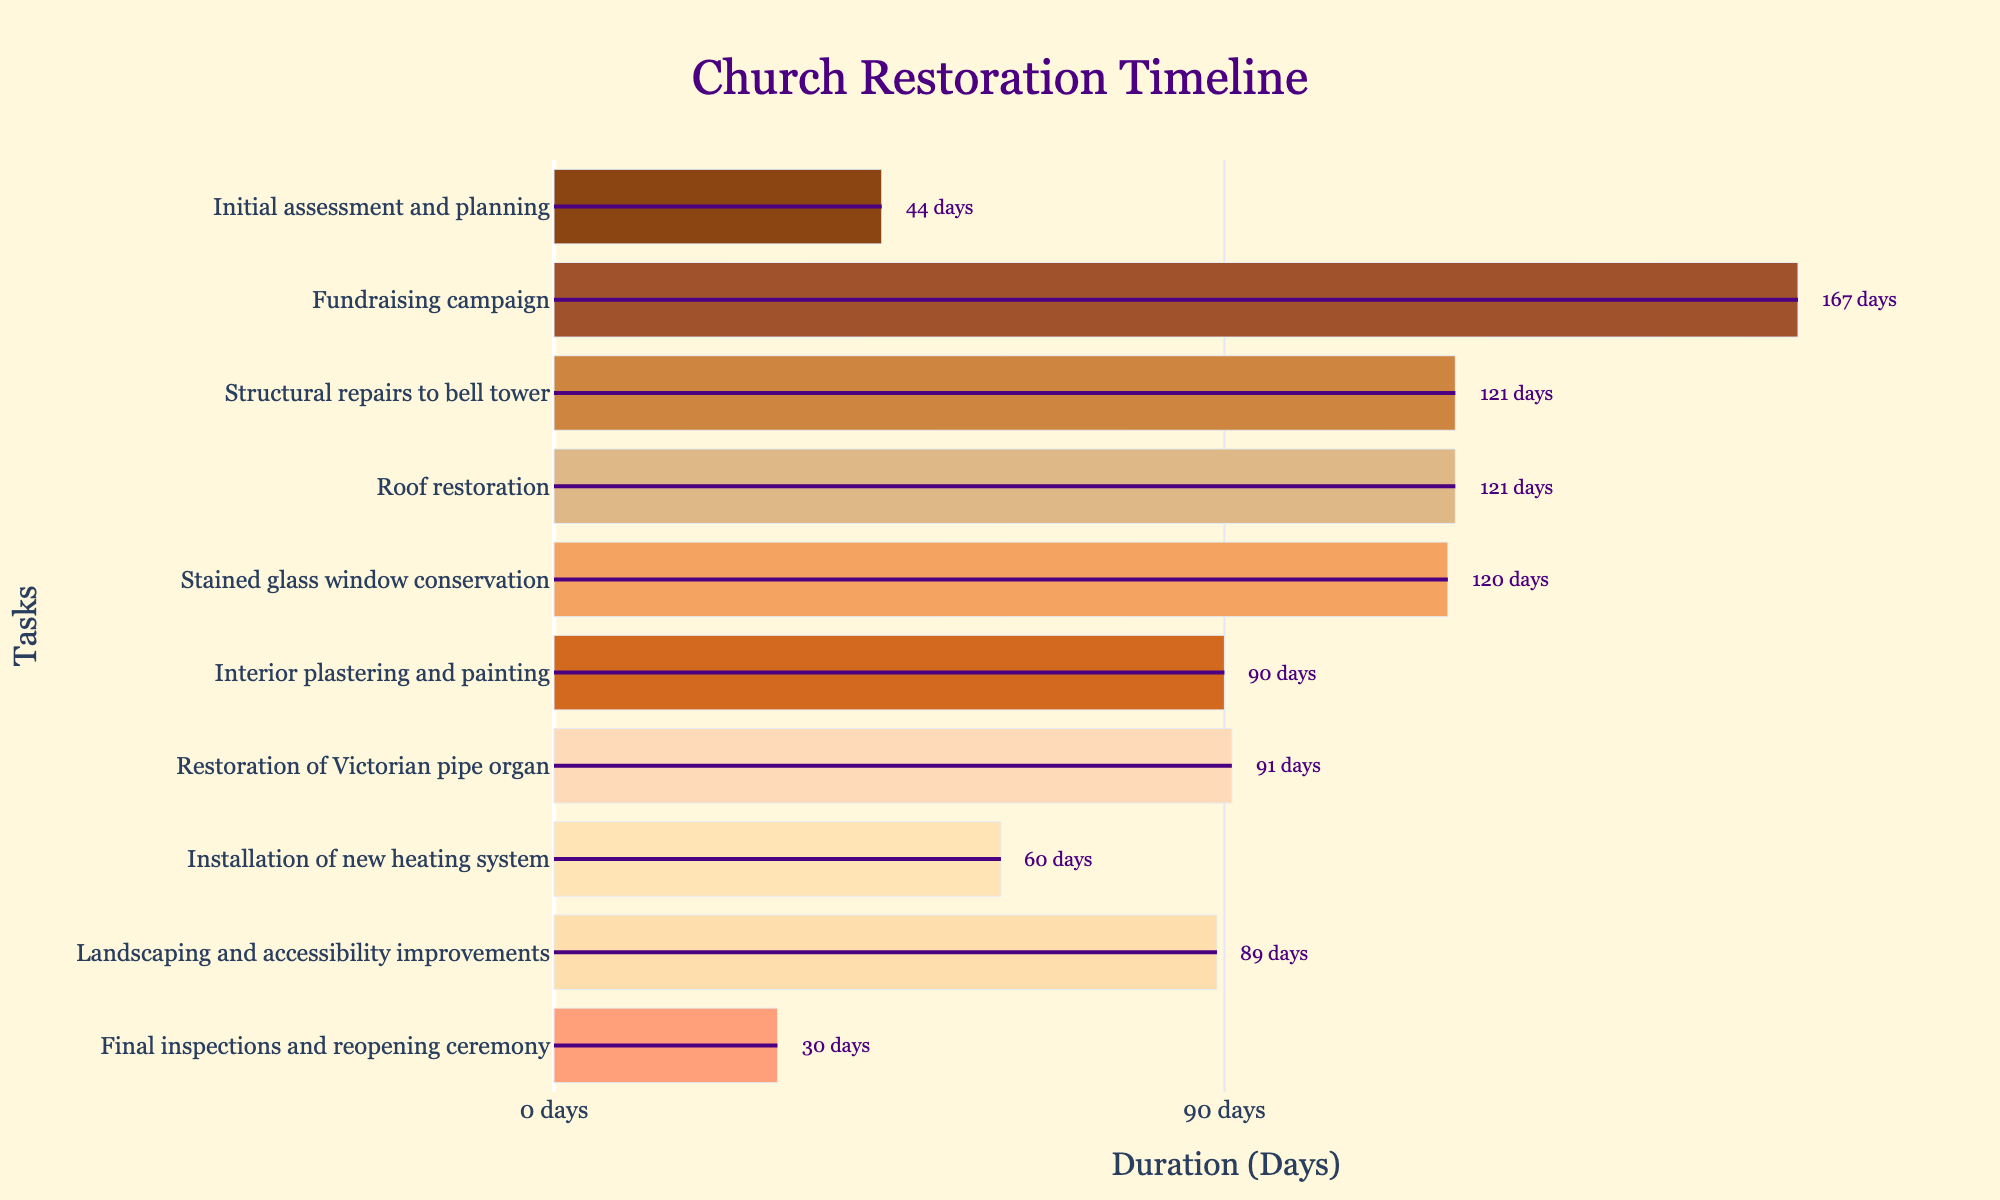what is the title of the chart? The title of the chart is given at the top center of the figure. It reads "Church Restoration Timeline".
Answer: Church Restoration Timeline What is the duration of the "Roof restoration" task? The "Roof restoration" task starts on August 1, 2024, and ends on November 30, 2024. The difference between these dates is 122 days.
Answer: 122 days Which task has the shortest duration? Looking at the chart, the task with the shortest bar length (duration) is the "Final inspections and reopening ceremony," lasting 31 days.
Answer: Final inspections and reopening ceremony How much longer does the "Fundraising campaign" run compared to the "Initial assessment and planning"? The "Fundraising campaign" lasts from October 16, 2023, to March 31, 2024, which is 167 days. The "Initial assessment and planning" lasts from September 1, 2023, to October 15, 2023, which is 45 days. The difference is 167 - 45 = 122 days.
Answer: 122 days Which tasks are scheduled to end in 2025? The tasks ending in 2025 are "Interior plastering and painting" (June 30, 2025), "Restoration of Victorian pipe organ" (September 30, 2025), and "Installation of new heating system" (November 30, 2025).
Answer: Interior plastering and painting, Restoration of Victorian pipe organ, Installation of new heating system During which months in 2024 do the "Structural repairs to bell tower" and "Roof restoration" overlap? The "Structural repairs to bell tower" runs from April 1, 2024, to July 31, 2024, and "Roof restoration" runs from August 1, 2024, to November 30, 2024. They don't overlap as one ends on July 31, and the other starts on August 1.
Answer: They don't overlap What task begins immediately after the "Stained glass window conservation"? The "Stained glass window conservation" ends on March 31, 2025. The next task, starting on April 1, 2025, is "Interior plastering and painting".
Answer: Interior plastering and painting How many tasks are expected to be active at any time in July 2025? From the chart, looking at July 2025: the "Restoration of Victorian pipe organ" runs from July 1, 2025, to September 30, 2025. "Interior plastering and painting" ends on June 30, 2025. Therefore, only one task is active in July 2025.
Answer: 1 task 